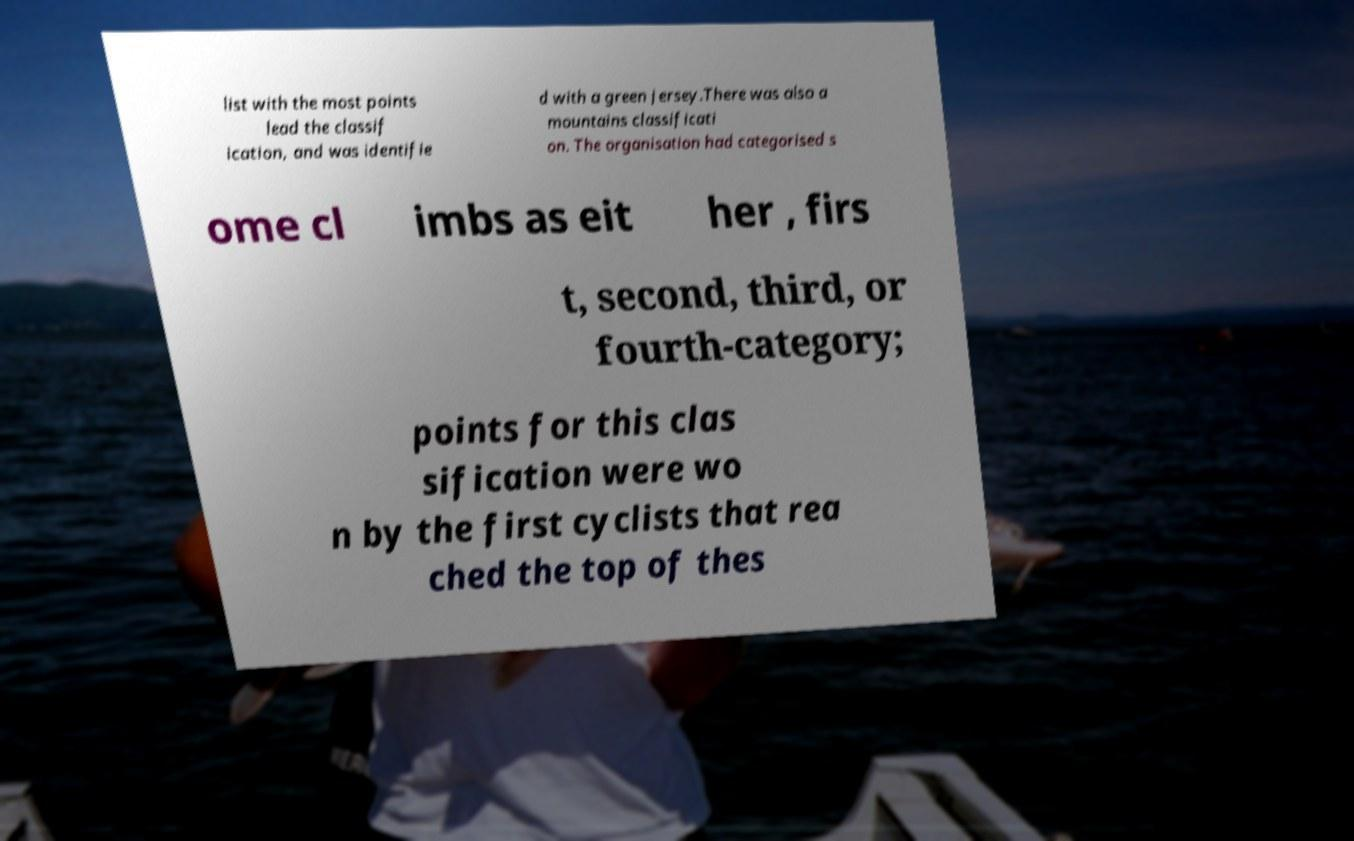Could you extract and type out the text from this image? list with the most points lead the classif ication, and was identifie d with a green jersey.There was also a mountains classificati on. The organisation had categorised s ome cl imbs as eit her , firs t, second, third, or fourth-category; points for this clas sification were wo n by the first cyclists that rea ched the top of thes 